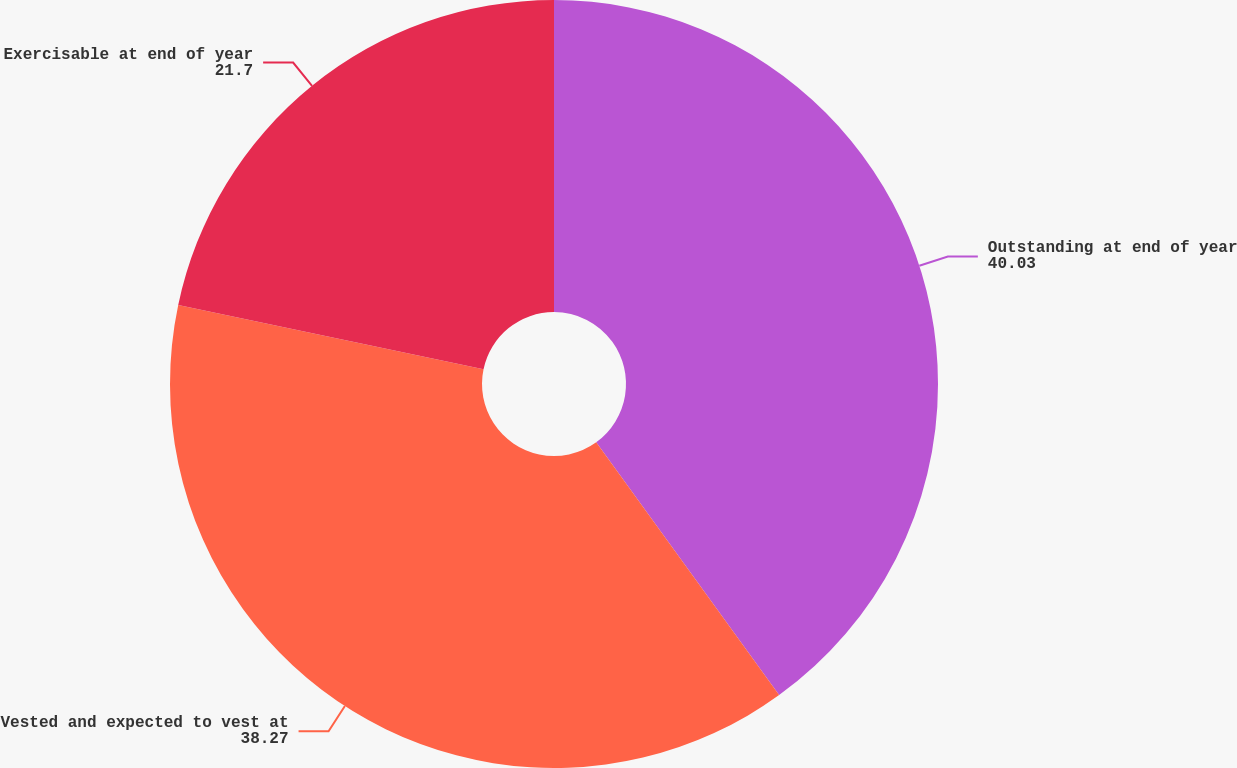Convert chart. <chart><loc_0><loc_0><loc_500><loc_500><pie_chart><fcel>Outstanding at end of year<fcel>Vested and expected to vest at<fcel>Exercisable at end of year<nl><fcel>40.03%<fcel>38.27%<fcel>21.7%<nl></chart> 